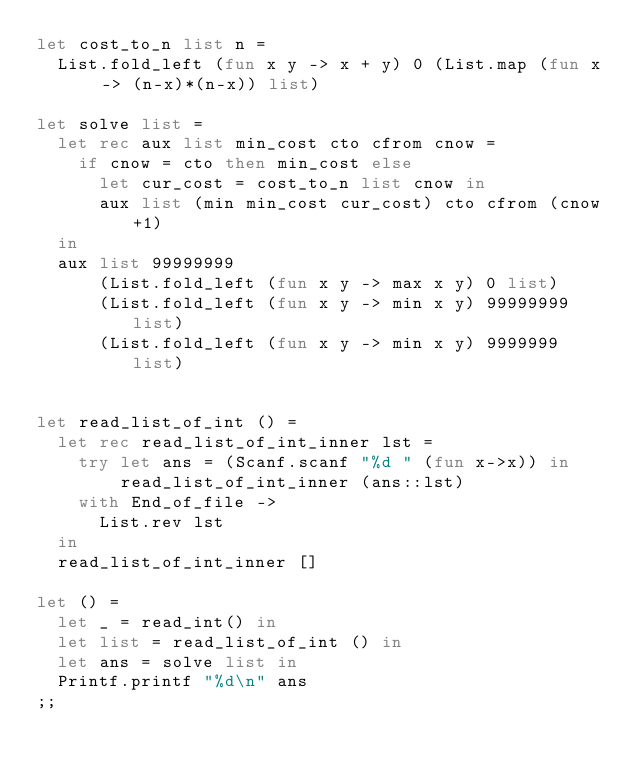Convert code to text. <code><loc_0><loc_0><loc_500><loc_500><_OCaml_>let cost_to_n list n =
  List.fold_left (fun x y -> x + y) 0 (List.map (fun x -> (n-x)*(n-x)) list)

let solve list =
  let rec aux list min_cost cto cfrom cnow =
    if cnow = cto then min_cost else
      let cur_cost = cost_to_n list cnow in
      aux list (min min_cost cur_cost) cto cfrom (cnow+1)
  in
  aux list 99999999
      (List.fold_left (fun x y -> max x y) 0 list)
      (List.fold_left (fun x y -> min x y) 99999999 list)
      (List.fold_left (fun x y -> min x y) 9999999 list)
    

let read_list_of_int () =
  let rec read_list_of_int_inner lst =
    try let ans = (Scanf.scanf "%d " (fun x->x)) in
        read_list_of_int_inner (ans::lst)
    with End_of_file ->
      List.rev lst
  in
  read_list_of_int_inner []

let () =
  let _ = read_int() in
  let list = read_list_of_int () in
  let ans = solve list in
  Printf.printf "%d\n" ans
;;</code> 